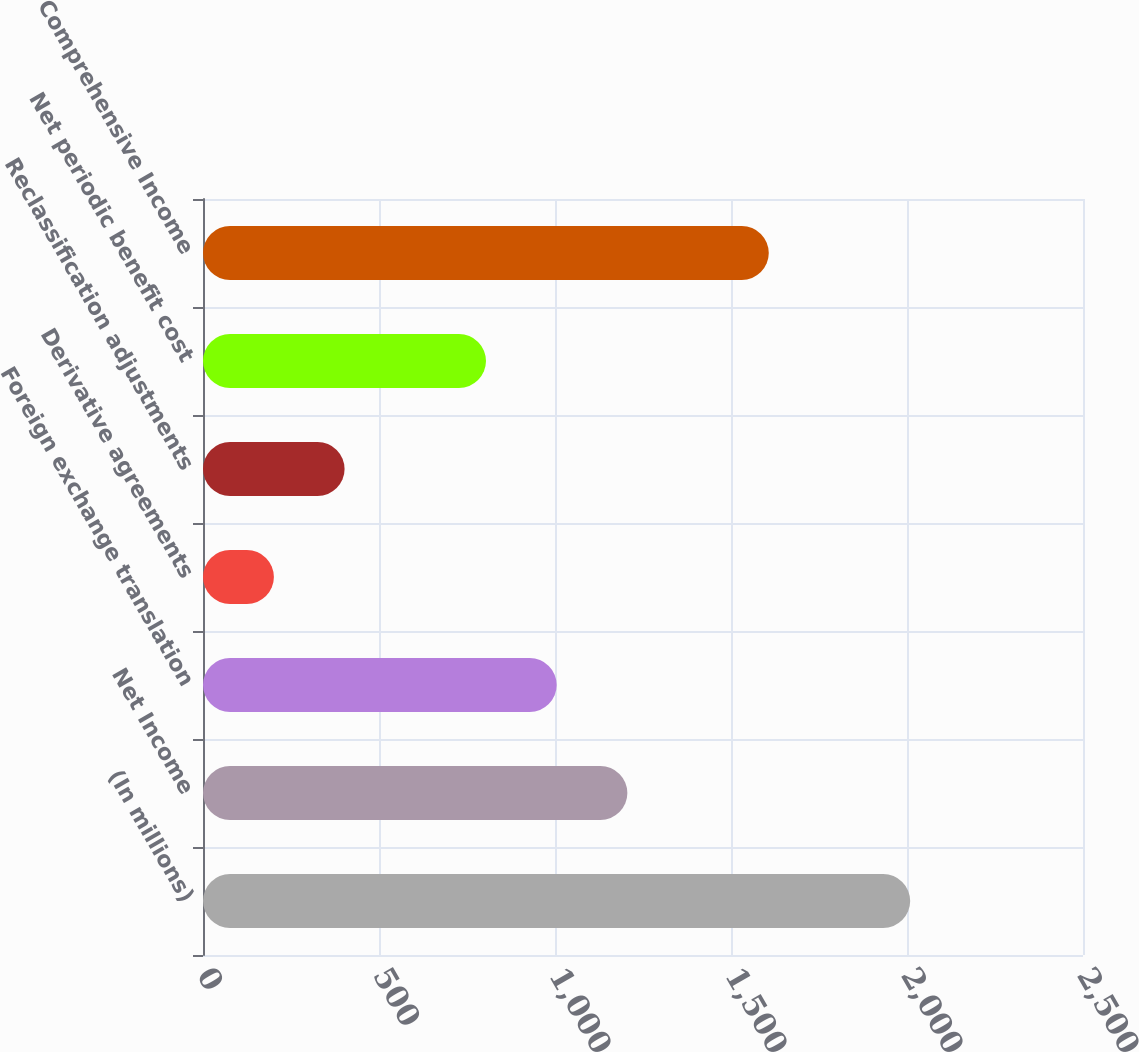Convert chart. <chart><loc_0><loc_0><loc_500><loc_500><bar_chart><fcel>(In millions)<fcel>Net Income<fcel>Foreign exchange translation<fcel>Derivative agreements<fcel>Reclassification adjustments<fcel>Net periodic benefit cost<fcel>Comprehensive Income<nl><fcel>2009<fcel>1205.61<fcel>1004.77<fcel>201.41<fcel>402.25<fcel>803.93<fcel>1607.29<nl></chart> 